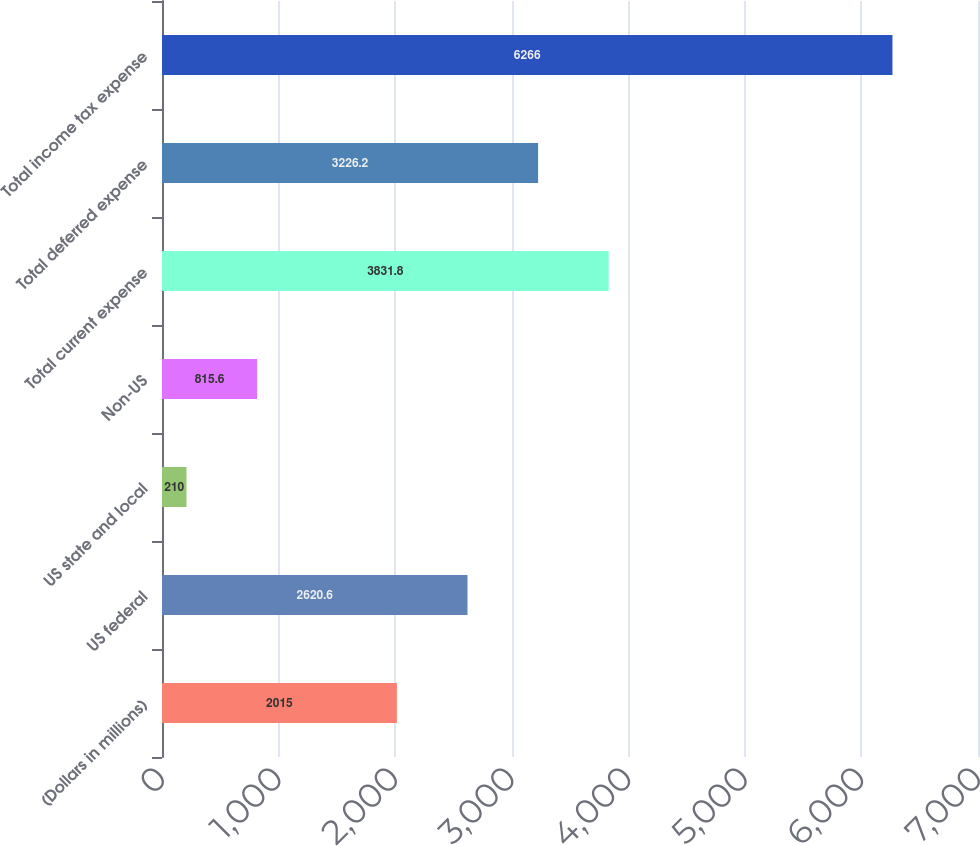Convert chart. <chart><loc_0><loc_0><loc_500><loc_500><bar_chart><fcel>(Dollars in millions)<fcel>US federal<fcel>US state and local<fcel>Non-US<fcel>Total current expense<fcel>Total deferred expense<fcel>Total income tax expense<nl><fcel>2015<fcel>2620.6<fcel>210<fcel>815.6<fcel>3831.8<fcel>3226.2<fcel>6266<nl></chart> 